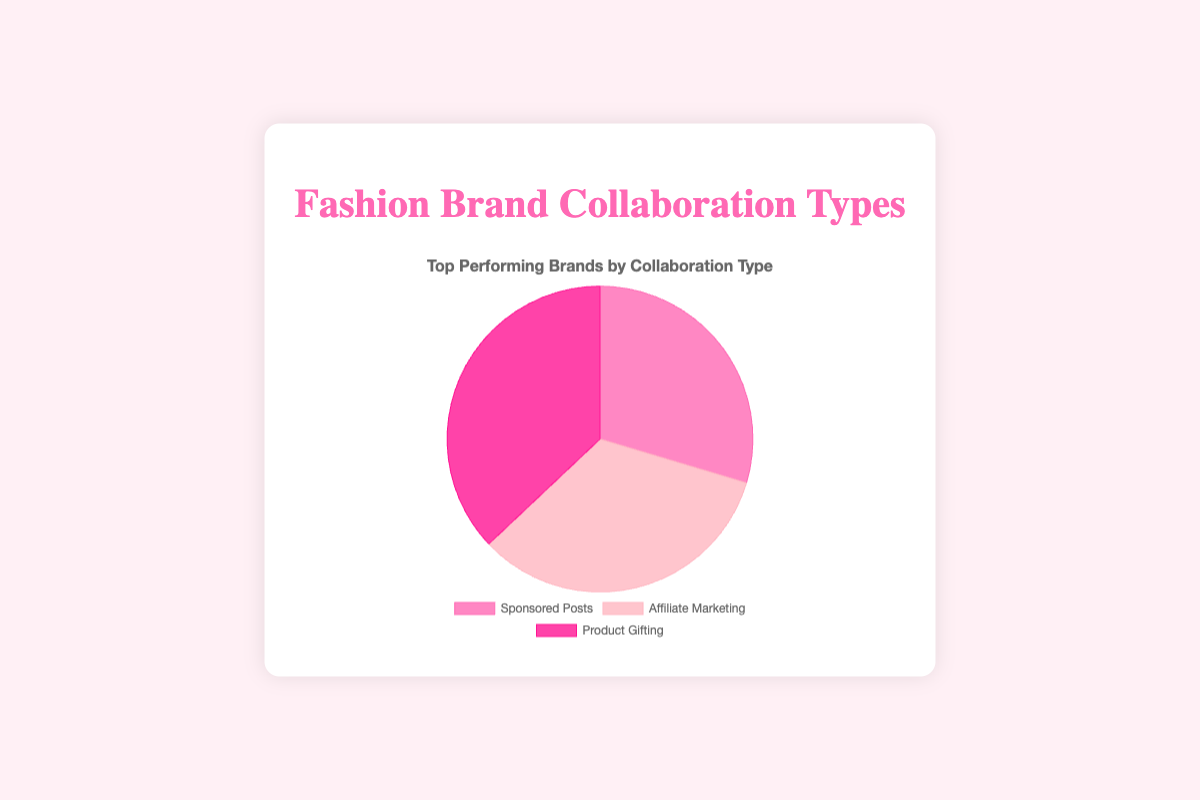What's the most common type of brand collaboration shown in the chart? The chart shows a pie with three types of collaborations. By looking at the largest slice, we can identify the most common type.
Answer: Product Gifting Which brand has the highest percentage in the 'Sponsored Posts' collaboration type? Within the 'Sponsored Posts' segment, the top brand is mentioned in the tooltip and is Fashion Nova with 40%.
Answer: Fashion Nova How does the percentage of 'Affiliate Marketing' collaborations with Nordstrom compare to those with Revolve? For 'Affiliate Marketing', Nordstrom has a 35% share and Revolve has 20%. Therefore, Nordstrom has a higher percentage than Revolve.
Answer: Nordstrom is higher What is the combined percentage of 'Sponsored Posts' collaborations attributed to ASOS and Zara? ASOS has 30% and Zara has 30% within the 'Sponsored Posts' category. Adding these together, we get 30% + 30% = 60%.
Answer: 60% Which type of collaboration features the highest percentage for any single brand, and what is that percentage? By reviewing the tooltip information, Chanel in 'Product Gifting' has the highest individual percentage at 50%.
Answer: Product Gifting, 50% How does the percentage of 'Product Gifting' collaborations with Dior compare to the smallest percentage brand within 'Affiliate Marketing'? Within 'Product Gifting', Dior has a 25% share. The smallest 'Affiliate Marketing' percentage is for Revolve at 20%. Comparing the two, Dior's percentage is higher.
Answer: Dior is higher What is the total percentage of the largest brand contributions across all collaboration types shown? Summing the largest contributions: Fashion Nova (40%) from 'Sponsored Posts', Amazon Fashion (45%) from 'Affiliate Marketing', and Chanel (50%) from 'Product Gifting'. The total is 40% + 45% + 50% = 135%.
Answer: 135% How does the color of the 'Affiliate Marketing' segment visually compare to the 'Sponsored Posts' segment in terms of darkness? The 'Affiliate Marketing' segment is a lighter pink compared to the 'Sponsored Posts', which is a darker pink.
Answer: 'Affiliate Marketing' is lighter 